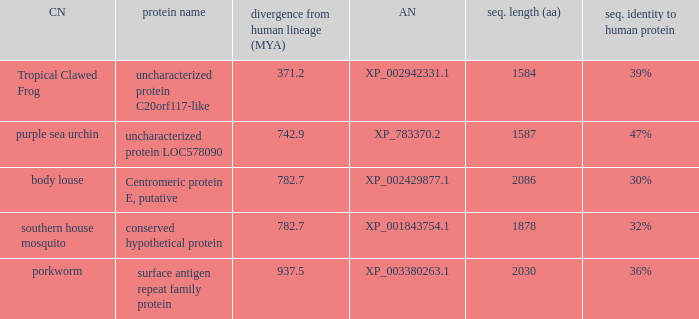What is the sequence length (aa) of the protein with the common name Purple Sea Urchin and a divergence from human lineage less than 742.9? None. 